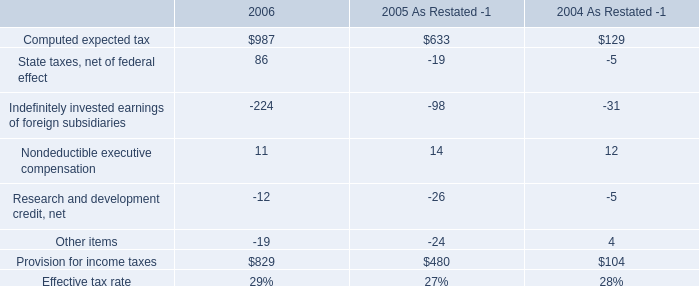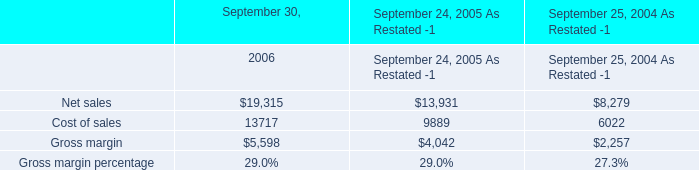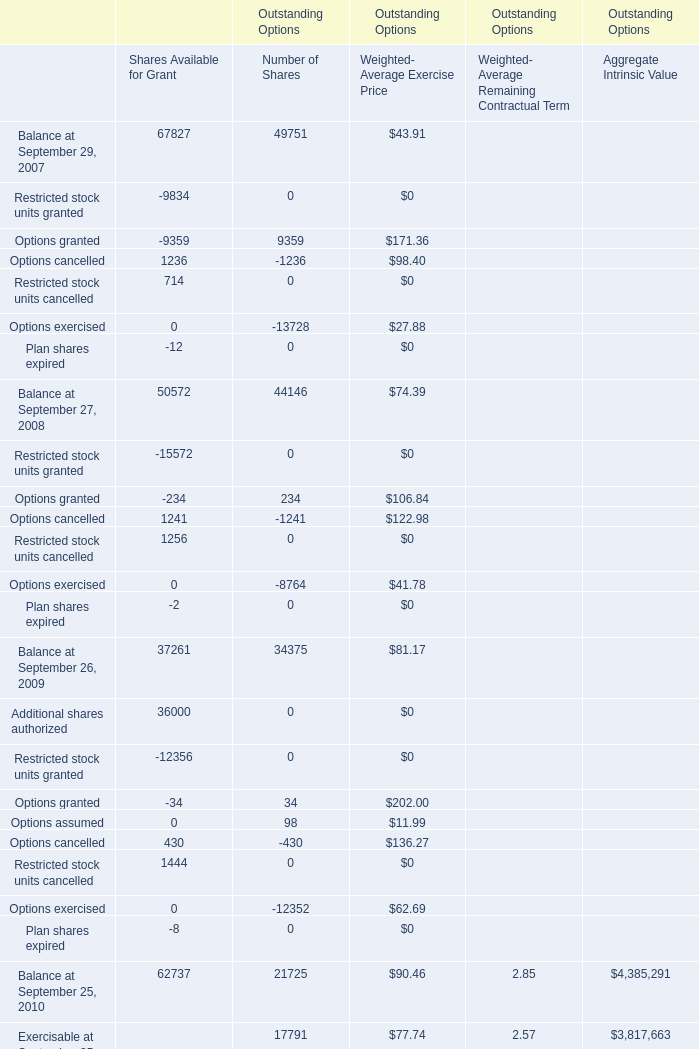In which year is Restricted stock units cancelled positive? 
Answer: 20082009.0. 